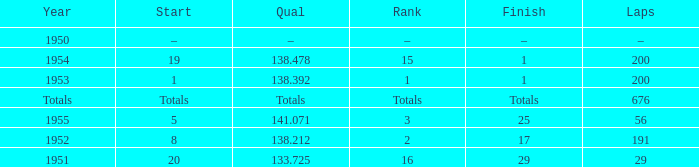What is the start of the race with 676 laps? Totals. 